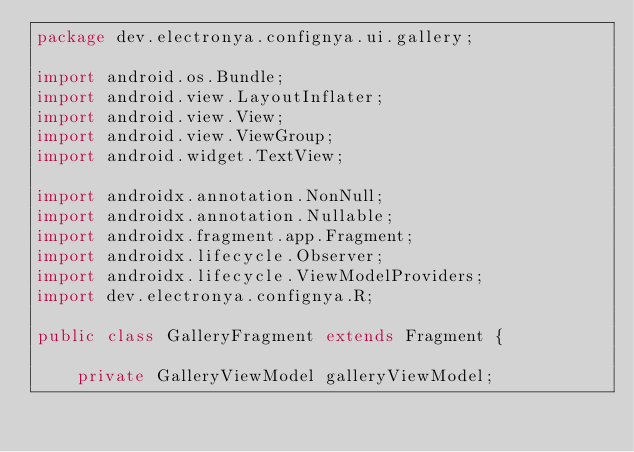<code> <loc_0><loc_0><loc_500><loc_500><_Java_>package dev.electronya.confignya.ui.gallery;

import android.os.Bundle;
import android.view.LayoutInflater;
import android.view.View;
import android.view.ViewGroup;
import android.widget.TextView;

import androidx.annotation.NonNull;
import androidx.annotation.Nullable;
import androidx.fragment.app.Fragment;
import androidx.lifecycle.Observer;
import androidx.lifecycle.ViewModelProviders;
import dev.electronya.confignya.R;

public class GalleryFragment extends Fragment {

    private GalleryViewModel galleryViewModel;
</code> 